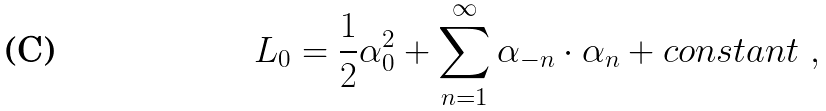<formula> <loc_0><loc_0><loc_500><loc_500>L _ { 0 } = { \frac { 1 } { 2 } } \alpha _ { 0 } ^ { 2 } + \sum _ { n = 1 } ^ { \infty } \alpha _ { - n } \cdot \alpha _ { n } + c o n s t a n t \ ,</formula> 